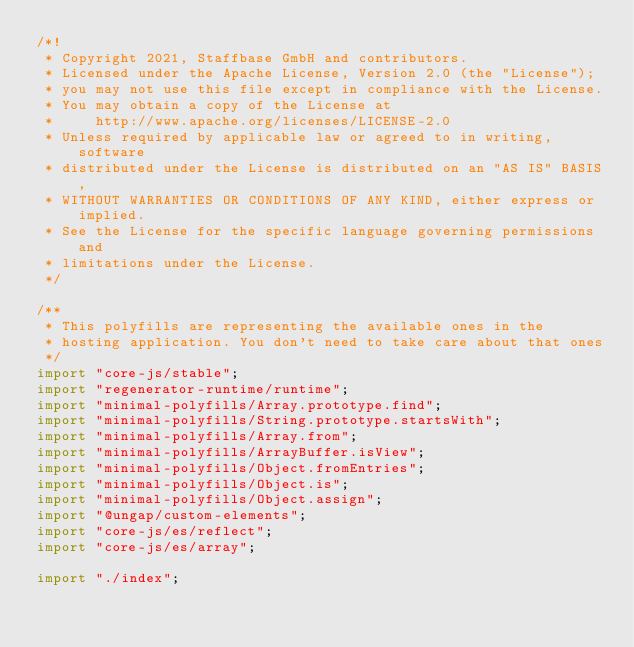Convert code to text. <code><loc_0><loc_0><loc_500><loc_500><_TypeScript_>/*!
 * Copyright 2021, Staffbase GmbH and contributors.
 * Licensed under the Apache License, Version 2.0 (the "License");
 * you may not use this file except in compliance with the License.
 * You may obtain a copy of the License at
 *     http://www.apache.org/licenses/LICENSE-2.0
 * Unless required by applicable law or agreed to in writing, software
 * distributed under the License is distributed on an "AS IS" BASIS,
 * WITHOUT WARRANTIES OR CONDITIONS OF ANY KIND, either express or implied.
 * See the License for the specific language governing permissions and
 * limitations under the License.
 */

/**
 * This polyfills are representing the available ones in the
 * hosting application. You don't need to take care about that ones
 */
import "core-js/stable";
import "regenerator-runtime/runtime";
import "minimal-polyfills/Array.prototype.find";
import "minimal-polyfills/String.prototype.startsWith";
import "minimal-polyfills/Array.from";
import "minimal-polyfills/ArrayBuffer.isView";
import "minimal-polyfills/Object.fromEntries";
import "minimal-polyfills/Object.is";
import "minimal-polyfills/Object.assign";
import "@ungap/custom-elements";
import "core-js/es/reflect";
import "core-js/es/array";

import "./index";
</code> 